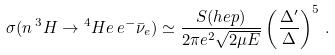Convert formula to latex. <formula><loc_0><loc_0><loc_500><loc_500>\sigma ( n \, { ^ { 3 } H } \to { ^ { 4 } { H e } } \, e ^ { - } { \bar { \nu } } _ { e } ) \simeq \frac { S ( h e p ) } { 2 \pi e ^ { 2 } \sqrt { 2 \mu E } } \left ( \frac { \Delta ^ { \prime } } { \Delta } \right ) ^ { 5 } \, .</formula> 